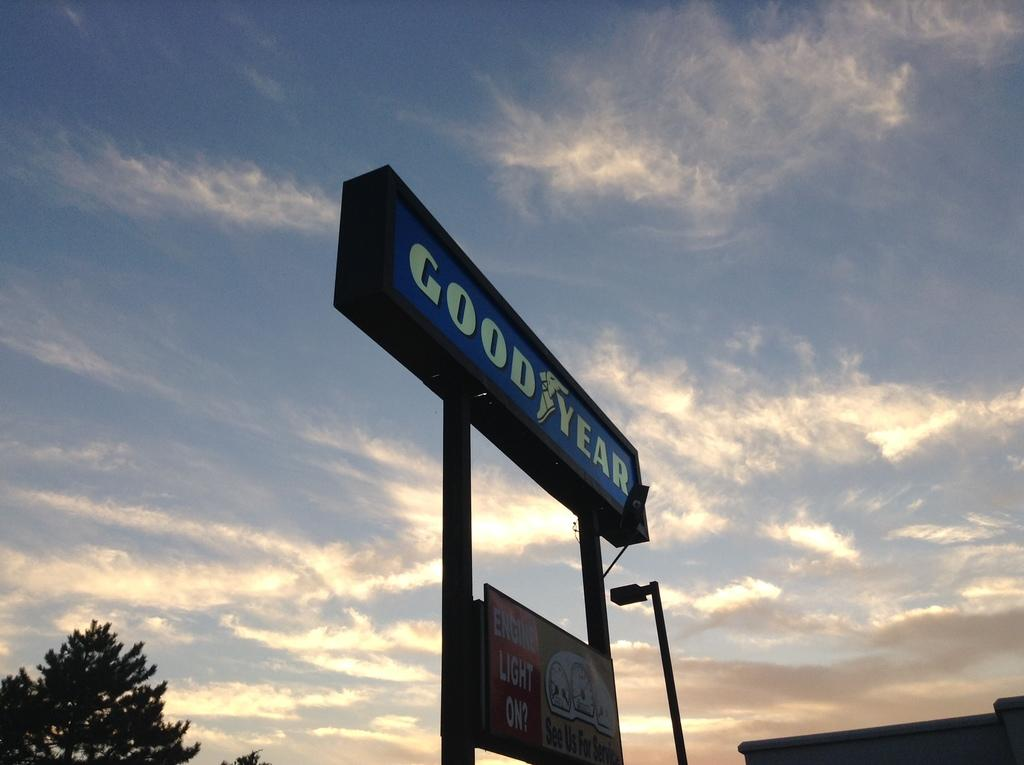<image>
Provide a brief description of the given image. A sign says Good Year and a sunset is in the background. 